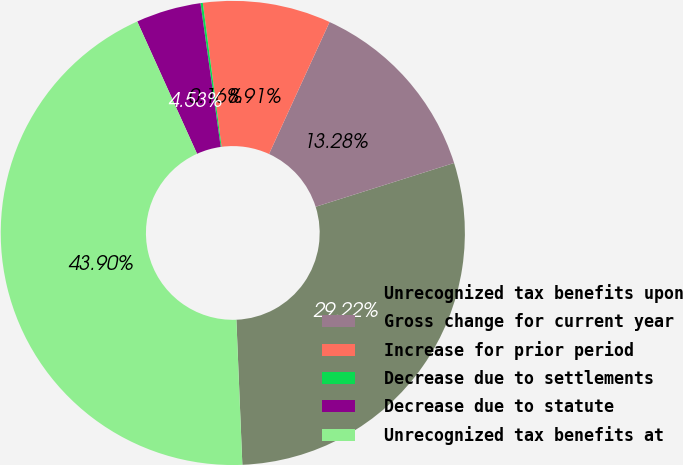<chart> <loc_0><loc_0><loc_500><loc_500><pie_chart><fcel>Unrecognized tax benefits upon<fcel>Gross change for current year<fcel>Increase for prior period<fcel>Decrease due to settlements<fcel>Decrease due to statute<fcel>Unrecognized tax benefits at<nl><fcel>29.22%<fcel>13.28%<fcel>8.91%<fcel>0.16%<fcel>4.53%<fcel>43.9%<nl></chart> 